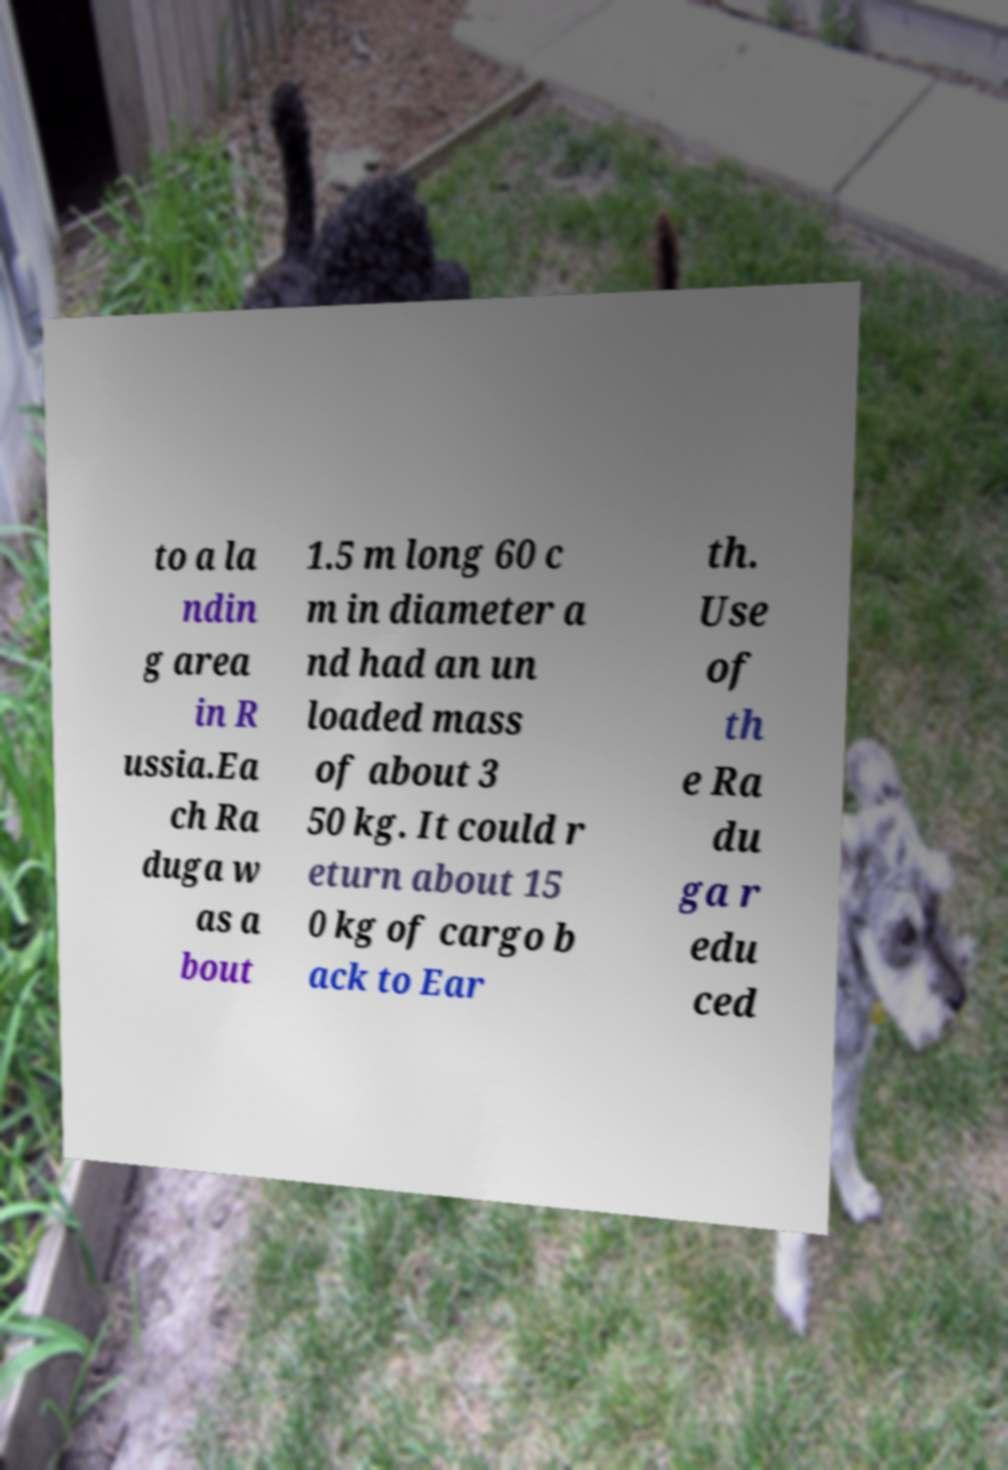Can you read and provide the text displayed in the image?This photo seems to have some interesting text. Can you extract and type it out for me? to a la ndin g area in R ussia.Ea ch Ra duga w as a bout 1.5 m long 60 c m in diameter a nd had an un loaded mass of about 3 50 kg. It could r eturn about 15 0 kg of cargo b ack to Ear th. Use of th e Ra du ga r edu ced 